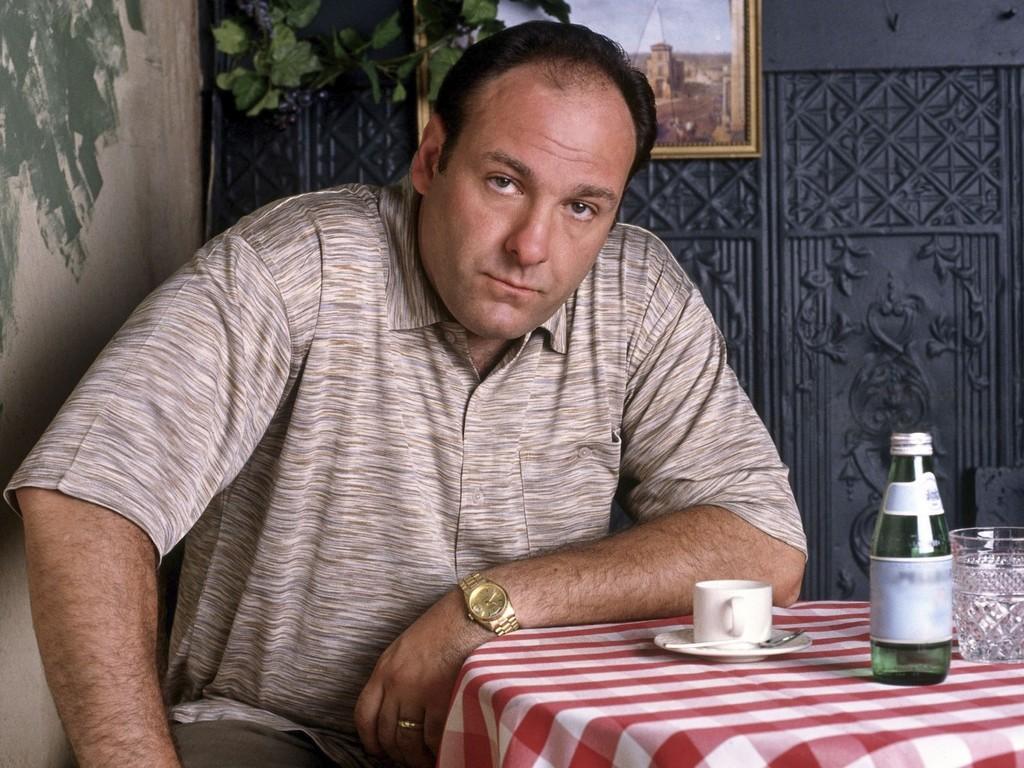Describe this image in one or two sentences. In this image there is a man sitting in chair near the table , and there are cup , spoon , saucer , glass in table and in back ground there is wall , plant , and a frame. 